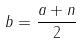Convert formula to latex. <formula><loc_0><loc_0><loc_500><loc_500>b = \frac { a + n } { 2 }</formula> 